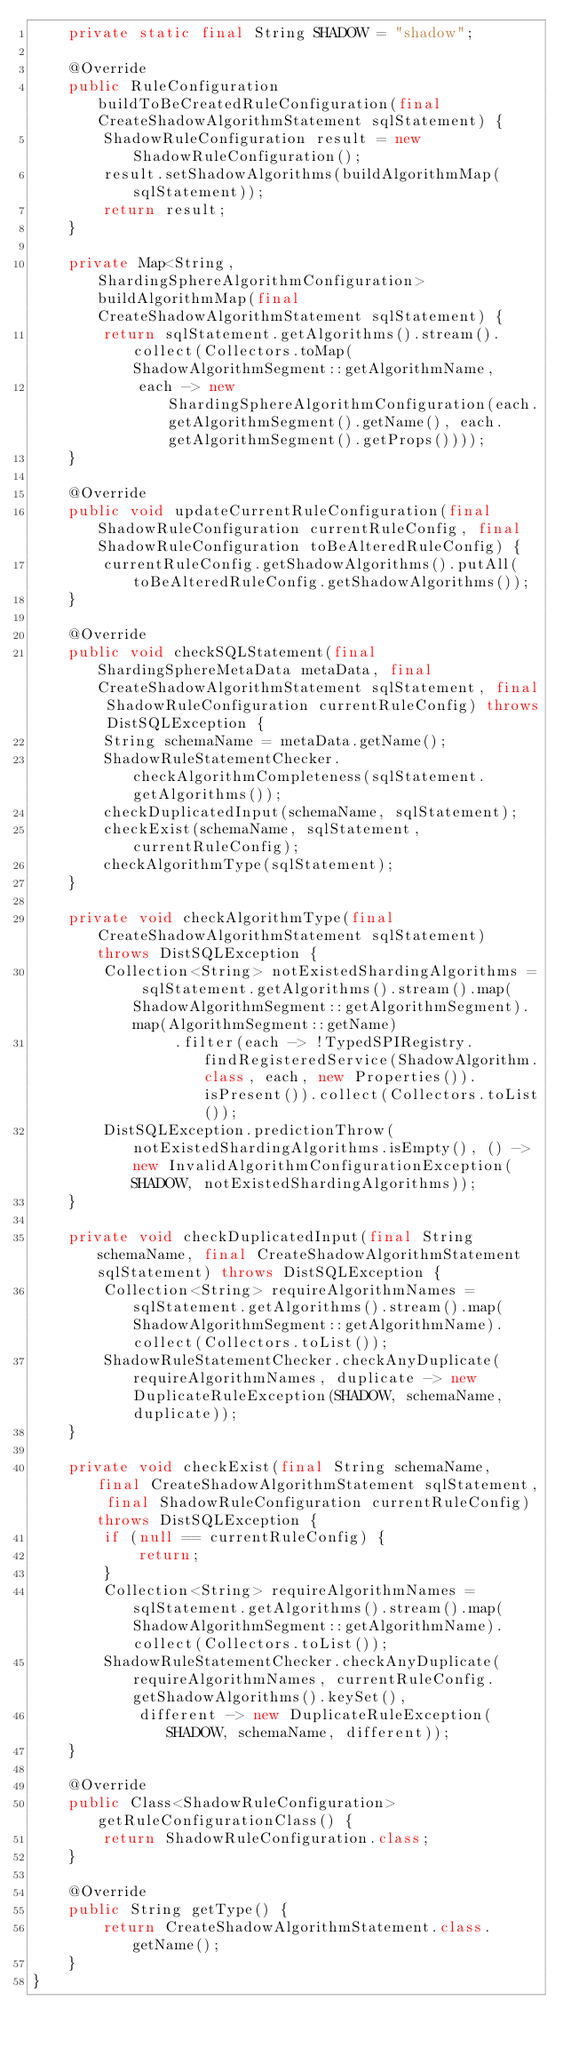Convert code to text. <code><loc_0><loc_0><loc_500><loc_500><_Java_>    private static final String SHADOW = "shadow";
    
    @Override
    public RuleConfiguration buildToBeCreatedRuleConfiguration(final CreateShadowAlgorithmStatement sqlStatement) {
        ShadowRuleConfiguration result = new ShadowRuleConfiguration();
        result.setShadowAlgorithms(buildAlgorithmMap(sqlStatement));
        return result;
    }
    
    private Map<String, ShardingSphereAlgorithmConfiguration> buildAlgorithmMap(final CreateShadowAlgorithmStatement sqlStatement) {
        return sqlStatement.getAlgorithms().stream().collect(Collectors.toMap(ShadowAlgorithmSegment::getAlgorithmName,
            each -> new ShardingSphereAlgorithmConfiguration(each.getAlgorithmSegment().getName(), each.getAlgorithmSegment().getProps())));
    }
    
    @Override
    public void updateCurrentRuleConfiguration(final ShadowRuleConfiguration currentRuleConfig, final ShadowRuleConfiguration toBeAlteredRuleConfig) {
        currentRuleConfig.getShadowAlgorithms().putAll(toBeAlteredRuleConfig.getShadowAlgorithms());
    }
    
    @Override
    public void checkSQLStatement(final ShardingSphereMetaData metaData, final CreateShadowAlgorithmStatement sqlStatement, final ShadowRuleConfiguration currentRuleConfig) throws DistSQLException {
        String schemaName = metaData.getName();
        ShadowRuleStatementChecker.checkAlgorithmCompleteness(sqlStatement.getAlgorithms());
        checkDuplicatedInput(schemaName, sqlStatement);
        checkExist(schemaName, sqlStatement, currentRuleConfig);
        checkAlgorithmType(sqlStatement);
    }
    
    private void checkAlgorithmType(final CreateShadowAlgorithmStatement sqlStatement) throws DistSQLException {
        Collection<String> notExistedShardingAlgorithms = sqlStatement.getAlgorithms().stream().map(ShadowAlgorithmSegment::getAlgorithmSegment).map(AlgorithmSegment::getName)
                .filter(each -> !TypedSPIRegistry.findRegisteredService(ShadowAlgorithm.class, each, new Properties()).isPresent()).collect(Collectors.toList());
        DistSQLException.predictionThrow(notExistedShardingAlgorithms.isEmpty(), () -> new InvalidAlgorithmConfigurationException(SHADOW, notExistedShardingAlgorithms));
    }
    
    private void checkDuplicatedInput(final String schemaName, final CreateShadowAlgorithmStatement sqlStatement) throws DistSQLException {
        Collection<String> requireAlgorithmNames = sqlStatement.getAlgorithms().stream().map(ShadowAlgorithmSegment::getAlgorithmName).collect(Collectors.toList());
        ShadowRuleStatementChecker.checkAnyDuplicate(requireAlgorithmNames, duplicate -> new DuplicateRuleException(SHADOW, schemaName, duplicate));
    }
    
    private void checkExist(final String schemaName, final CreateShadowAlgorithmStatement sqlStatement, final ShadowRuleConfiguration currentRuleConfig) throws DistSQLException {
        if (null == currentRuleConfig) {
            return;
        }
        Collection<String> requireAlgorithmNames = sqlStatement.getAlgorithms().stream().map(ShadowAlgorithmSegment::getAlgorithmName).collect(Collectors.toList());
        ShadowRuleStatementChecker.checkAnyDuplicate(requireAlgorithmNames, currentRuleConfig.getShadowAlgorithms().keySet(),
            different -> new DuplicateRuleException(SHADOW, schemaName, different));
    }
    
    @Override
    public Class<ShadowRuleConfiguration> getRuleConfigurationClass() {
        return ShadowRuleConfiguration.class;
    }
    
    @Override
    public String getType() {
        return CreateShadowAlgorithmStatement.class.getName();
    }
}
</code> 